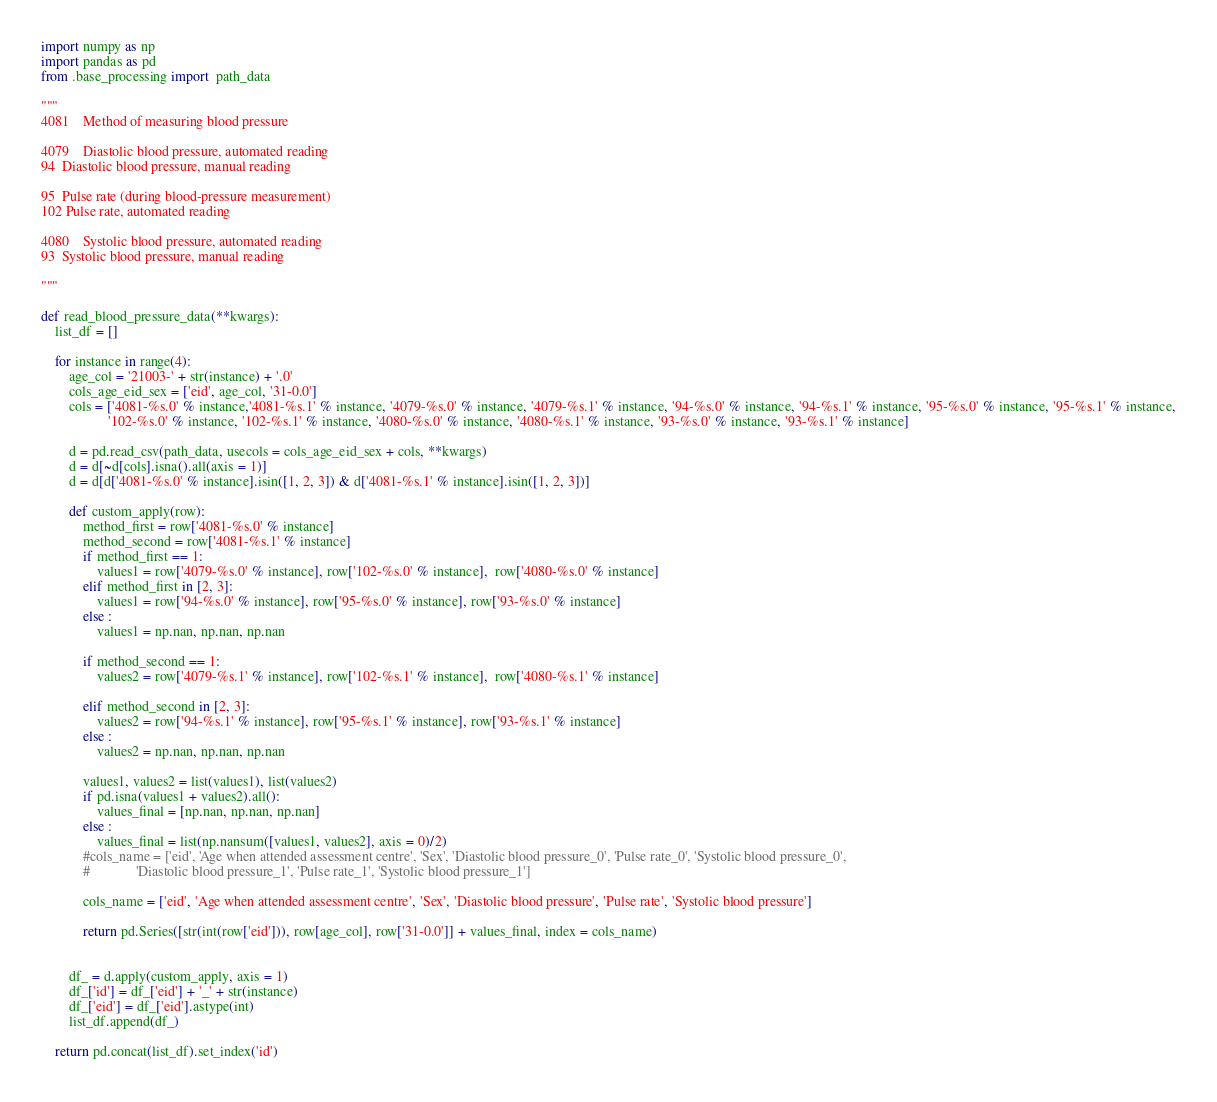<code> <loc_0><loc_0><loc_500><loc_500><_Python_>import numpy as np
import pandas as pd
from .base_processing import  path_data

"""
4081	Method of measuring blood pressure

4079	Diastolic blood pressure, automated reading
94	Diastolic blood pressure, manual reading

95	Pulse rate (during blood-pressure measurement)
102	Pulse rate, automated reading

4080	Systolic blood pressure, automated reading
93	Systolic blood pressure, manual reading

"""

def read_blood_pressure_data(**kwargs):
    list_df = []

    for instance in range(4):
        age_col = '21003-' + str(instance) + '.0'
        cols_age_eid_sex = ['eid', age_col, '31-0.0']
        cols = ['4081-%s.0' % instance,'4081-%s.1' % instance, '4079-%s.0' % instance, '4079-%s.1' % instance, '94-%s.0' % instance, '94-%s.1' % instance, '95-%s.0' % instance, '95-%s.1' % instance,
                   '102-%s.0' % instance, '102-%s.1' % instance, '4080-%s.0' % instance, '4080-%s.1' % instance, '93-%s.0' % instance, '93-%s.1' % instance]

        d = pd.read_csv(path_data, usecols = cols_age_eid_sex + cols, **kwargs)
        d = d[~d[cols].isna().all(axis = 1)]
        d = d[d['4081-%s.0' % instance].isin([1, 2, 3]) & d['4081-%s.1' % instance].isin([1, 2, 3])]

        def custom_apply(row):
            method_first = row['4081-%s.0' % instance]
            method_second = row['4081-%s.1' % instance]
            if method_first == 1:
                values1 = row['4079-%s.0' % instance], row['102-%s.0' % instance],  row['4080-%s.0' % instance]
            elif method_first in [2, 3]:
                values1 = row['94-%s.0' % instance], row['95-%s.0' % instance], row['93-%s.0' % instance]
            else :
                values1 = np.nan, np.nan, np.nan

            if method_second == 1:
                values2 = row['4079-%s.1' % instance], row['102-%s.1' % instance],  row['4080-%s.1' % instance]

            elif method_second in [2, 3]:
                values2 = row['94-%s.1' % instance], row['95-%s.1' % instance], row['93-%s.1' % instance]
            else :
                values2 = np.nan, np.nan, np.nan

            values1, values2 = list(values1), list(values2)
            if pd.isna(values1 + values2).all():
                values_final = [np.nan, np.nan, np.nan]
            else :
                values_final = list(np.nansum([values1, values2], axis = 0)/2)
            #cols_name = ['eid', 'Age when attended assessment centre', 'Sex', 'Diastolic blood pressure_0', 'Pulse rate_0', 'Systolic blood pressure_0',
            #             'Diastolic blood pressure_1', 'Pulse rate_1', 'Systolic blood pressure_1']

            cols_name = ['eid', 'Age when attended assessment centre', 'Sex', 'Diastolic blood pressure', 'Pulse rate', 'Systolic blood pressure']

            return pd.Series([str(int(row['eid'])), row[age_col], row['31-0.0']] + values_final, index = cols_name)


        df_ = d.apply(custom_apply, axis = 1)
        df_['id'] = df_['eid'] + '_' + str(instance)
        df_['eid'] = df_['eid'].astype(int)
        list_df.append(df_)

    return pd.concat(list_df).set_index('id')
</code> 